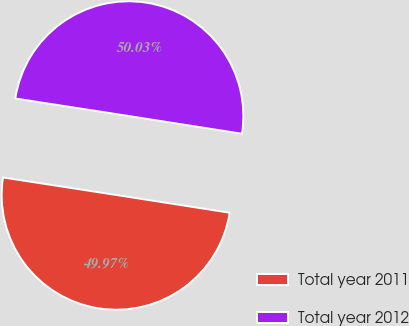Convert chart. <chart><loc_0><loc_0><loc_500><loc_500><pie_chart><fcel>Total year 2011<fcel>Total year 2012<nl><fcel>49.97%<fcel>50.03%<nl></chart> 